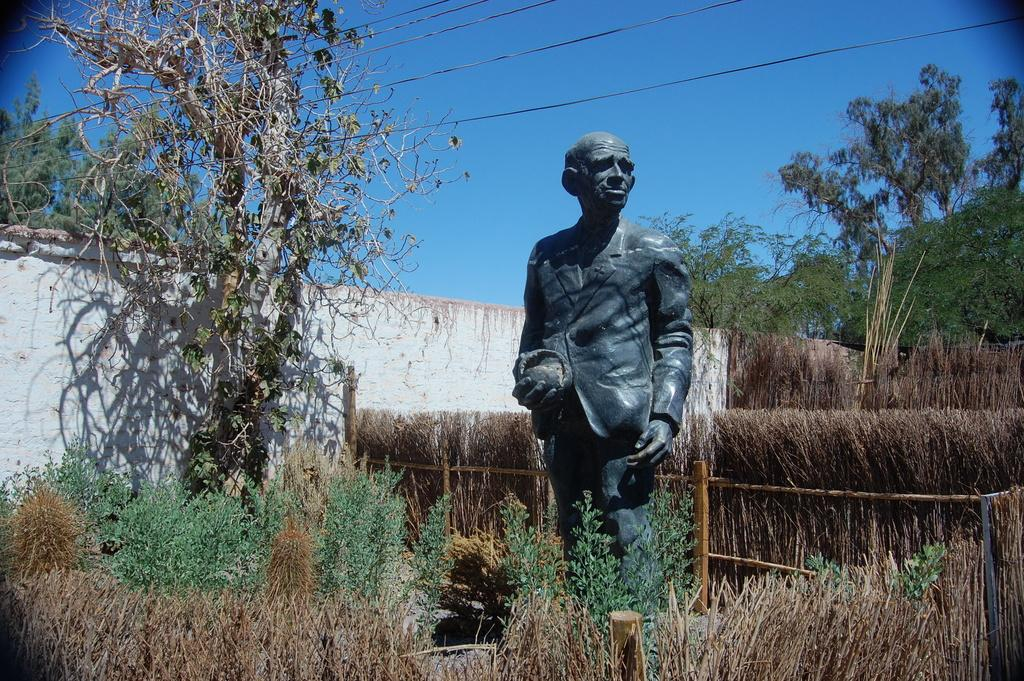What is the main subject in the image? There is a statue in the image. Where is the statue located? The statue is placed in a field. What can be seen around the field? Bushes surround the field, and trees are present around it. What is the color of the sky in the image? The sky is blue in the image. What type of powder is being used to clean the heart-shaped apparatus in the image? There is no powder, heart, or apparatus present in the image. 